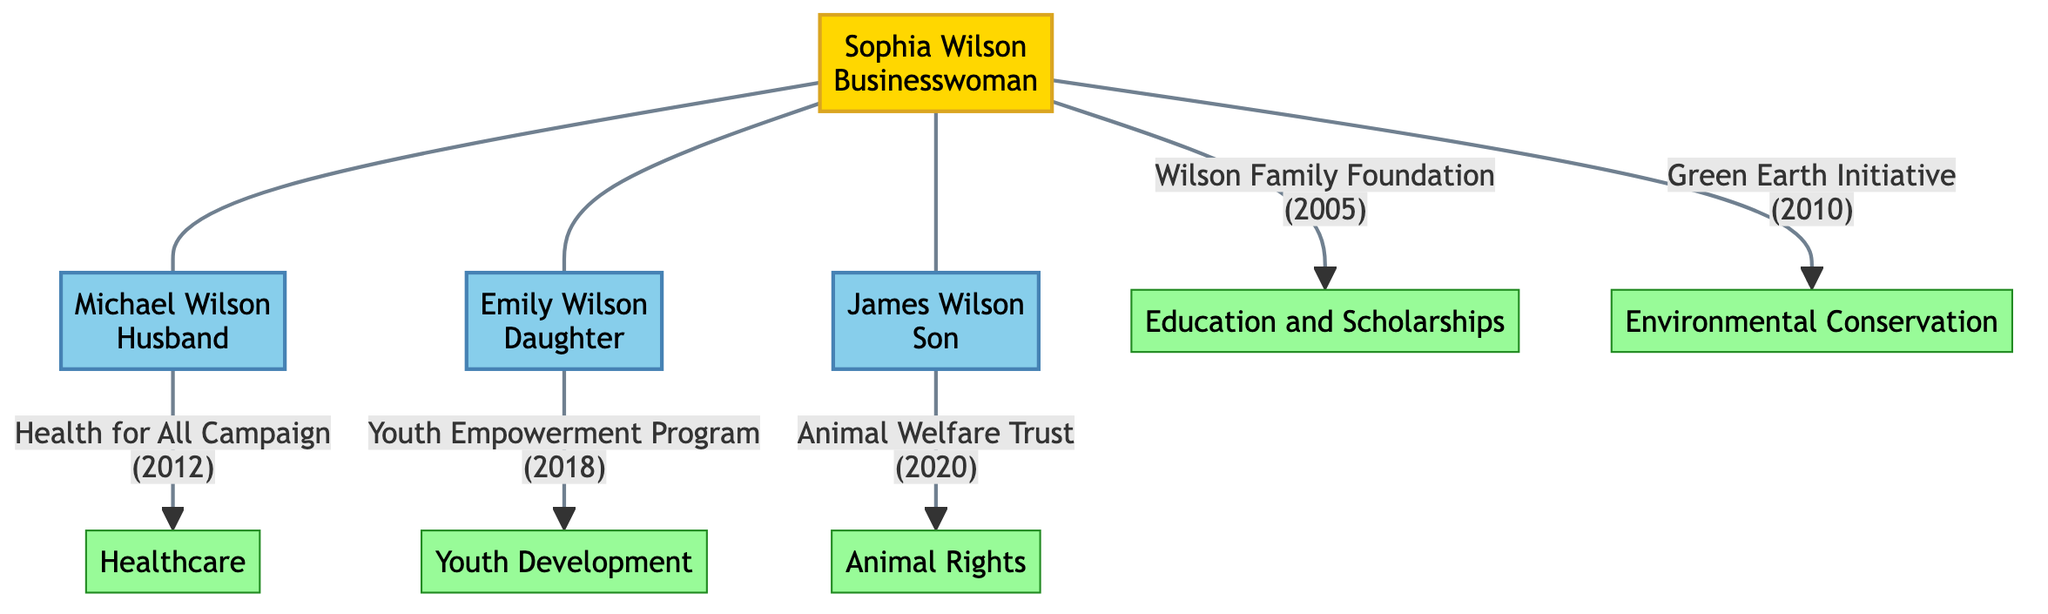What is the name of the protagonist in the diagram? The diagram labels the protagonist as "Sophia Wilson", who is the central figure and identified as a businesswoman.
Answer: Sophia Wilson Which philanthropic endeavor focuses on environmental conservation? In the diagram, the "Green Earth Initiative" is connected to Sophia Wilson and focuses on environmental conservation.
Answer: Green Earth Initiative How many philanthropic endeavors are associated with Sophia Wilson? The diagram shows that Sophia is connected to two philanthropic endeavors: the Wilson Family Foundation and the Green Earth Initiative.
Answer: 2 What is the focus area of the "Youth Empowerment Program"? The diagram indicates that the "Youth Empowerment Program" is associated with Emily Wilson and is focused on youth development.
Answer: Youth Development Which family member established the "Health for All Campaign"? The diagram specifies that Michael Wilson, Sophia's husband, is the one who established the "Health for All Campaign."
Answer: Michael Wilson What year was the "Animal Welfare Trust" established? According to the diagram, the "Animal Welfare Trust" was established in 2020, as indicated next to the program linked to James Wilson.
Answer: 2020 Who is the son in the family tree? The diagram clearly identifies James Wilson as the son of Sophia Wilson and Michael Wilson.
Answer: James Wilson Which endeavor was established most recently? By comparing the established years of all endeavors in the diagram, it's evident that the "Animal Welfare Trust," established in 2020, is the most recent.
Answer: Animal Welfare Trust What is the relationship between Sophia Wilson and Emily Wilson? The diagram shows a direct connection between Sophia Wilson and Emily Wilson, indicating that Emily is her daughter.
Answer: Mother-Daughter How many family members are depicted in the diagram? The diagram shows a total of four family members: Sophia Wilson, Michael Wilson, Emily Wilson, and James Wilson.
Answer: 4 